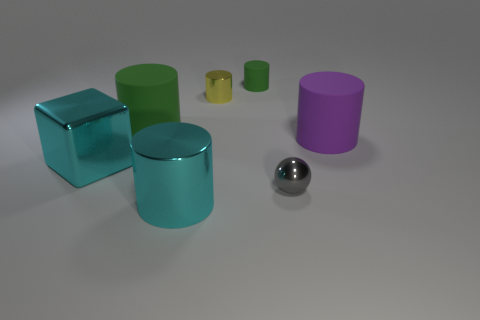Subtract all large shiny cylinders. How many cylinders are left? 4 Subtract all brown balls. How many green cylinders are left? 2 Subtract 1 cylinders. How many cylinders are left? 4 Subtract all cyan cylinders. How many cylinders are left? 4 Add 1 big green cylinders. How many objects exist? 8 Subtract all cyan cylinders. Subtract all blue cubes. How many cylinders are left? 4 Subtract all cubes. How many objects are left? 6 Subtract 0 gray blocks. How many objects are left? 7 Subtract all cyan things. Subtract all metal cylinders. How many objects are left? 3 Add 1 large green rubber cylinders. How many large green rubber cylinders are left? 2 